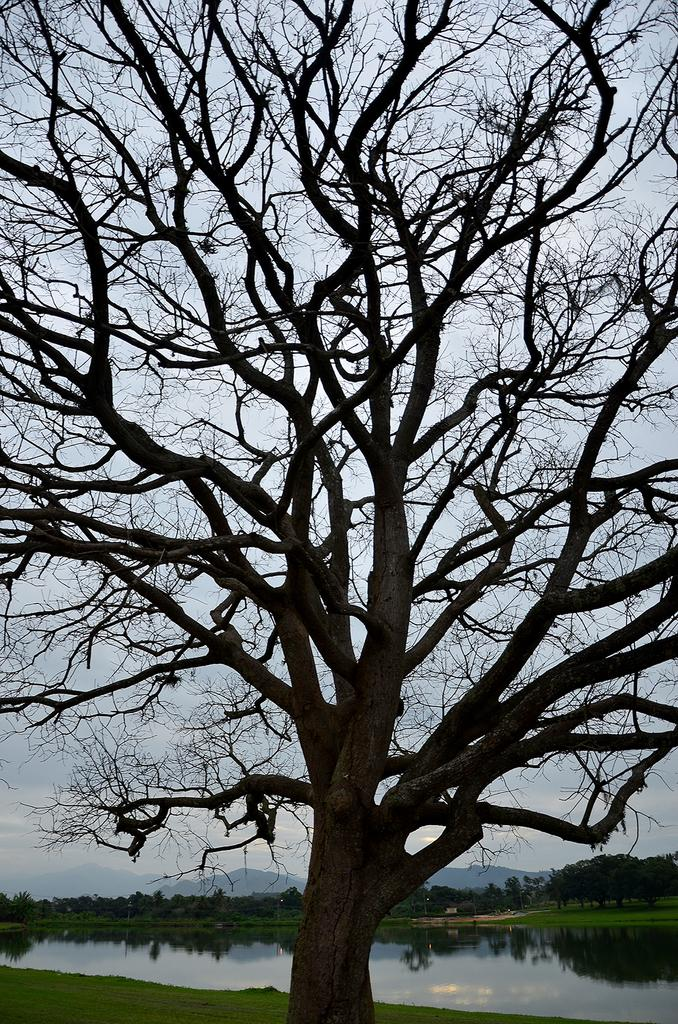What is the main subject in the center of the image? There is a tree in the center of the image. What is located at the bottom of the image? There is a pond at the bottom of the image. What can be seen in the background of the image? Hills and the sky are visible in the background of the image. What type of pen is being used to draw the memory in the image? There is no pen or memory depicted in the image; it features a tree, pond, hills, and sky. 